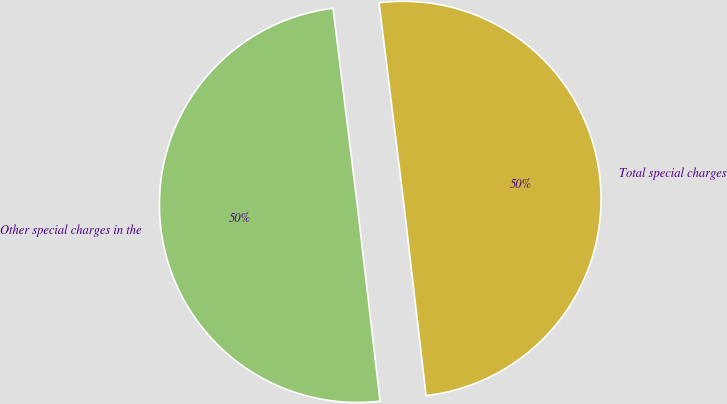Convert chart to OTSL. <chart><loc_0><loc_0><loc_500><loc_500><pie_chart><fcel>Other special charges in the<fcel>Total special charges<nl><fcel>49.89%<fcel>50.11%<nl></chart> 